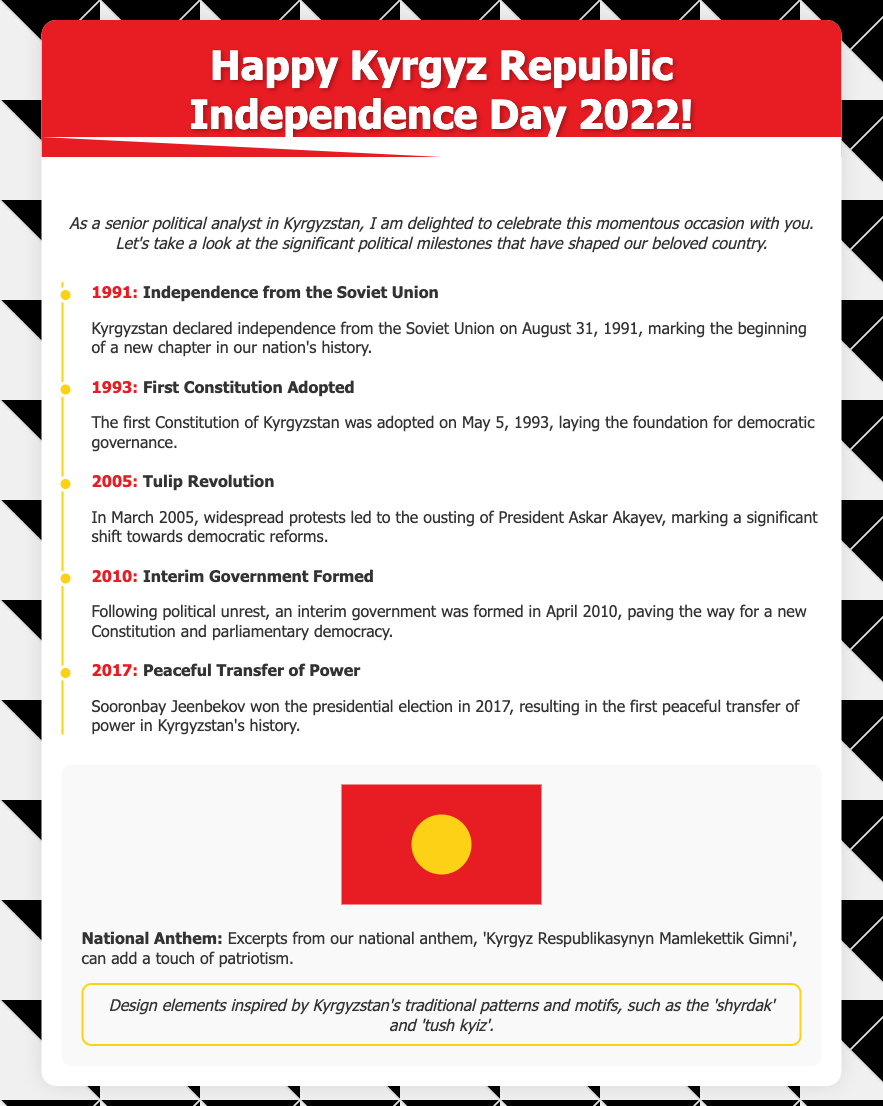What year did Kyrgyzstan declare independence? The document states that Kyrgyzstan declared independence from the Soviet Union on August 31, 1991.
Answer: 1991 What major event occurred in 2005? The document describes the Tulip Revolution in March 2005, which led to the ousting of President Askar Akayev.
Answer: Tulip Revolution What color is the background of the greeting card? The background color of the card is described as white in the content section.
Answer: White How many significant political milestones are outlined in the timeline? The document lists five significant political milestones that have shaped Kyrgyzstan.
Answer: Five What is the title of the national anthem mentioned? The document refers to the national anthem as 'Kyrgyz Respublikasynyn Mamlekettik Gimni'.
Answer: Kyrgyz Respublikasynyn Mamlekettik Gimni What notable constitutional event happened in 1993? The first Constitution of Kyrgyzstan was adopted on May 5, 1993, which is highlighted in the document.
Answer: First Constitution Adopted Which year marks the peaceful transfer of power? The timeline indicates that the peaceful transfer of power occurred in 2017 when Sooronbay Jeenbekov won the presidential election.
Answer: 2017 What design elements are inspired by Kyrgyz culture mentioned in the document? The document mentions traditional patterns and motifs like 'shyrdak' and 'tush kyiz' as part of the design elements.
Answer: Shyrdak and Tush Kyiz 